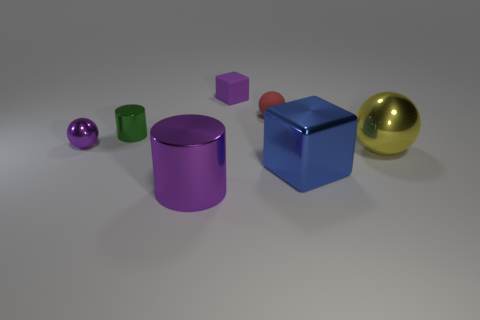Are there any green metallic cylinders behind the red matte object? Upon reviewing the scene, we can confirm that there are no green metallic cylinders positioned behind the red matte object. The only items situated in the vicinity are a matte blue cube and a shiny gold sphere. 